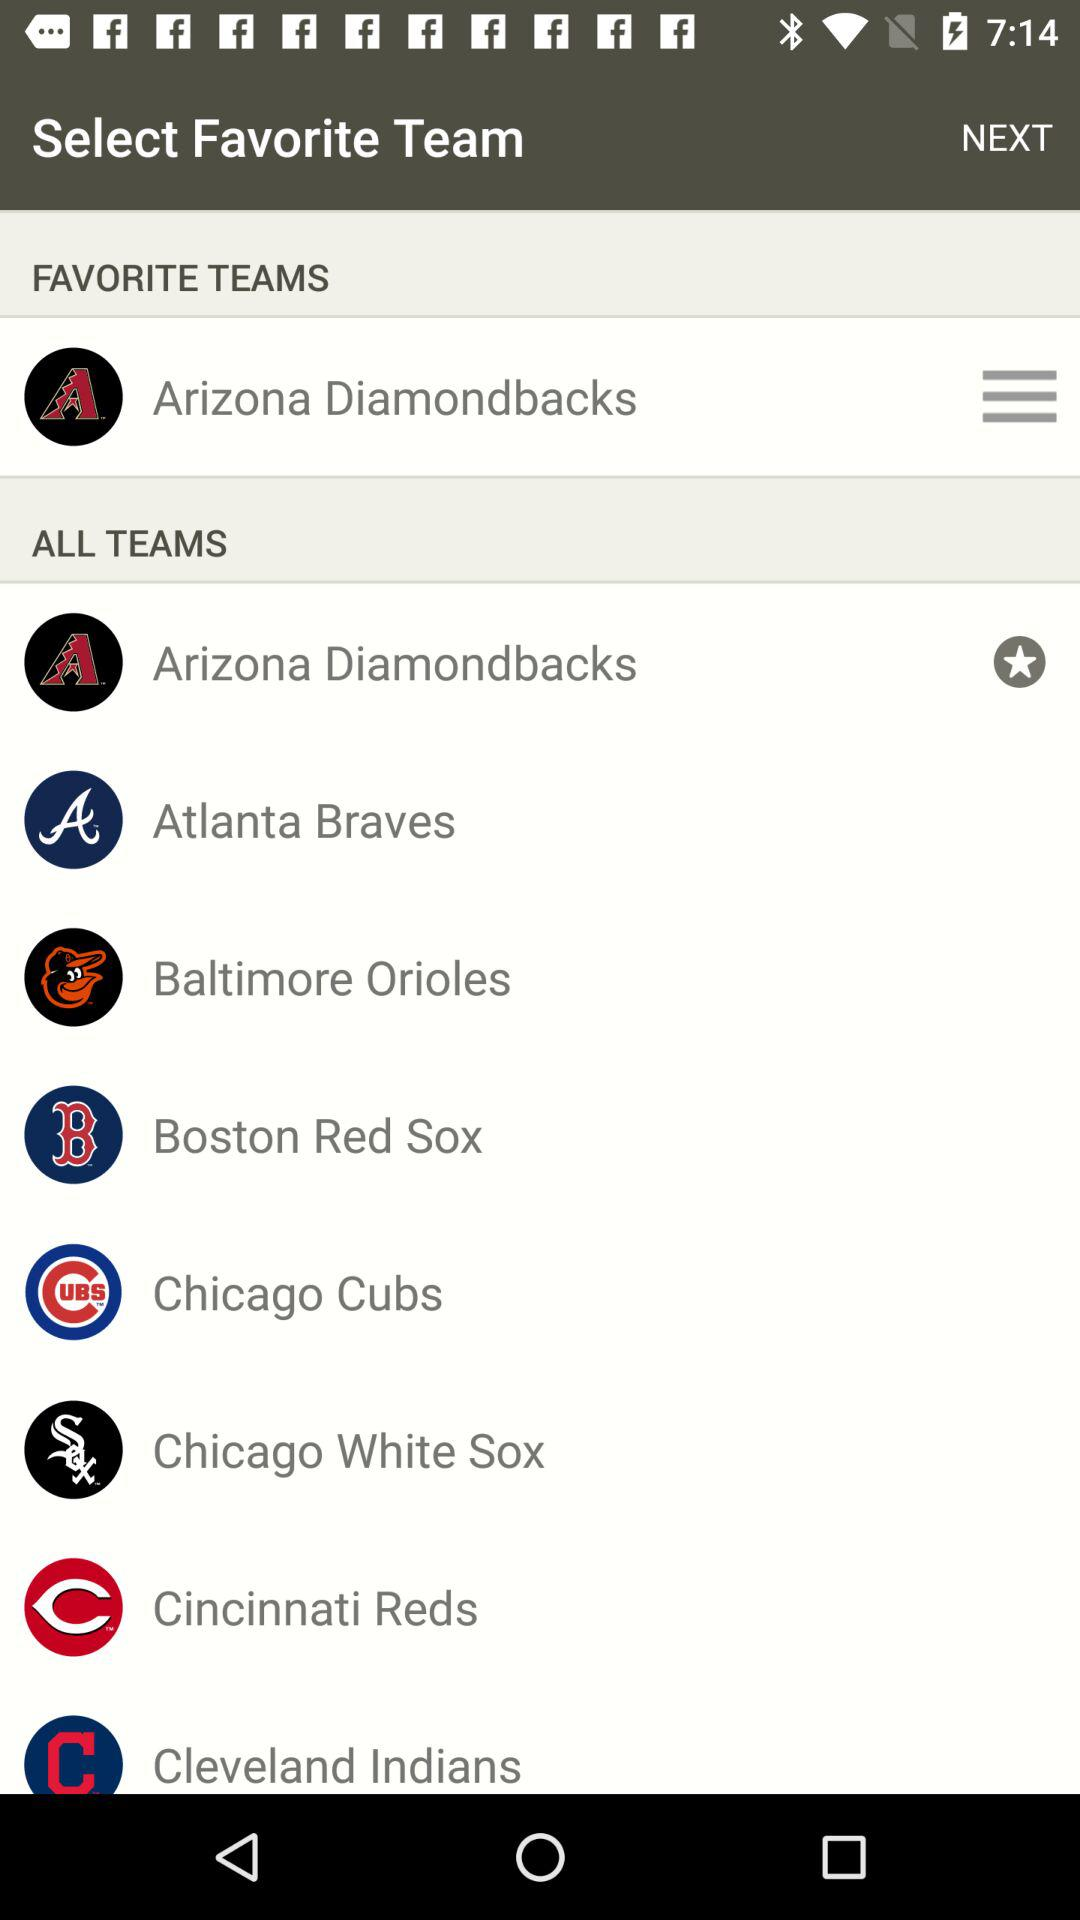What are the different teams? The different teams are "Arizona Diamondbacks", "Atlanta Braves", "Baltimore Orioles", "Boston Red Sox", "Chicago Cubs", "Chicago White Sox", "Cincinnati Reds" and "Cleveland Indians". 